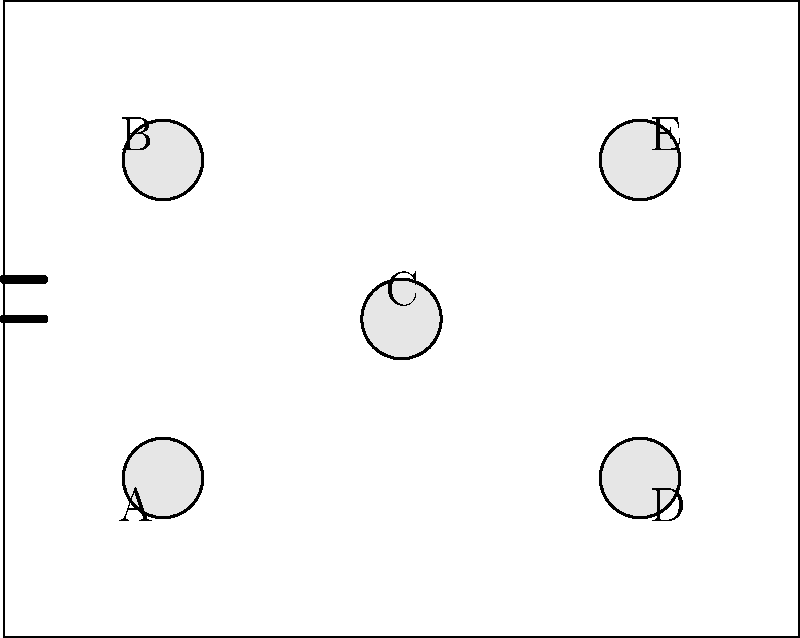Given the floor plan of your coffee shop, which shows five circular tables (A, B, C, D, and E) and an entrance, how would you arrange seating to maximize capacity for a book club meeting of 25 people while ensuring easy access to the entrance? Assume each table can comfortably seat up to 6 people. Provide the optimal distribution of guests among the tables and explain your reasoning. To solve this problem, we need to consider several factors:

1. Maximum capacity: Each table can seat up to 6 people, so the total maximum capacity is 30 (5 tables × 6 people).

2. Group size: We need to accommodate 25 people, which is less than the maximum capacity.

3. Entrance accessibility: We should prioritize leaving tables near the entrance (A and B) with some open seats for late arrivals and easy movement.

4. Even distribution: We want to distribute people as evenly as possible for better interaction.

Step-by-step solution:

1. Start by allocating 5 people to each table: 5 × 5 = 25 people
   This gives us an even distribution.

2. However, we want to leave some space at tables A and B near the entrance.
   Let's reduce their allocation to 4 people each.

3. We now have 4 + 4 + 5 + 5 + 5 = 23 people seated, with 2 more to place.

4. To maintain balance and accessibility, we'll add one person each to tables C and D.

Final distribution:
Table A: 4 people
Table B: 4 people
Table C: 6 people
Table D: 6 people
Table E: 5 people

This arrangement ensures:
- All 25 people are seated
- Tables near the entrance (A and B) have open seats for late arrivals
- The central table (C) and far tables (D and E) are fully or nearly fully utilized
- There's a relatively even distribution of guests
Answer: A: 4, B: 4, C: 6, D: 6, E: 5 